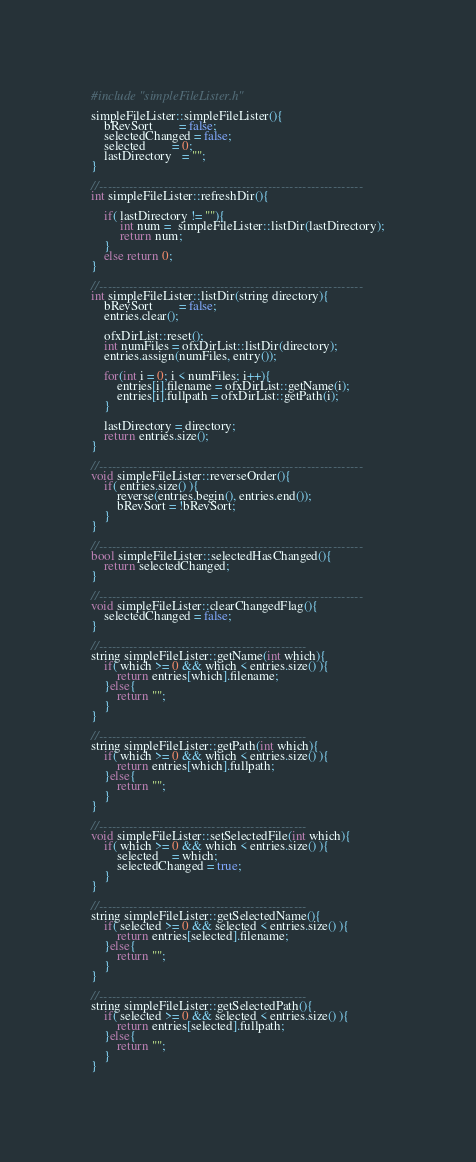<code> <loc_0><loc_0><loc_500><loc_500><_C++_>#include "simpleFileLister.h"

simpleFileLister::simpleFileLister(){
	bRevSort        = false;
	selectedChanged = false;
	selected        = 0;
	lastDirectory   = "";
}

//-------------------------------------------------------------
int simpleFileLister::refreshDir(){

	if( lastDirectory != ""){
		 int num =  simpleFileLister::listDir(lastDirectory);
		 return num;
	}
	else return 0;
}

//-------------------------------------------------------------
int simpleFileLister::listDir(string directory){
	bRevSort        = false;
	entries.clear();

	ofxDirList::reset();
	int numFiles = ofxDirList::listDir(directory);
	entries.assign(numFiles, entry());

	for(int i = 0; i < numFiles; i++){
		entries[i].filename = ofxDirList::getName(i);
		entries[i].fullpath = ofxDirList::getPath(i);
	}

	lastDirectory = directory;
	return entries.size();
}

//-------------------------------------------------------------
void simpleFileLister::reverseOrder(){
	if( entries.size() ){
		reverse(entries.begin(), entries.end());
		bRevSort = !bRevSort;
	}
}

//-------------------------------------------------------------
bool simpleFileLister::selectedHasChanged(){
	return selectedChanged;
}

//-------------------------------------------------------------
void simpleFileLister::clearChangedFlag(){
	selectedChanged = false;
}

//------------------------------------------------
string simpleFileLister::getName(int which){
	if( which >= 0 && which < entries.size() ){
		return entries[which].filename;
	}else{
		return "";
	}
}

//------------------------------------------------
string simpleFileLister::getPath(int which){
	if( which >= 0 && which < entries.size() ){
		return entries[which].fullpath;
	}else{
		return "";
	}
}

//------------------------------------------------
void simpleFileLister::setSelectedFile(int which){
	if( which >= 0 && which < entries.size() ){
		selected    = which;
		selectedChanged = true;
	}
}

//------------------------------------------------
string simpleFileLister::getSelectedName(){
	if( selected >= 0 && selected < entries.size() ){
		return entries[selected].filename;
	}else{
		return "";
	}
}

//------------------------------------------------
string simpleFileLister::getSelectedPath(){
	if( selected >= 0 && selected < entries.size() ){
		return entries[selected].fullpath;
	}else{
		return "";
	}
}
</code> 